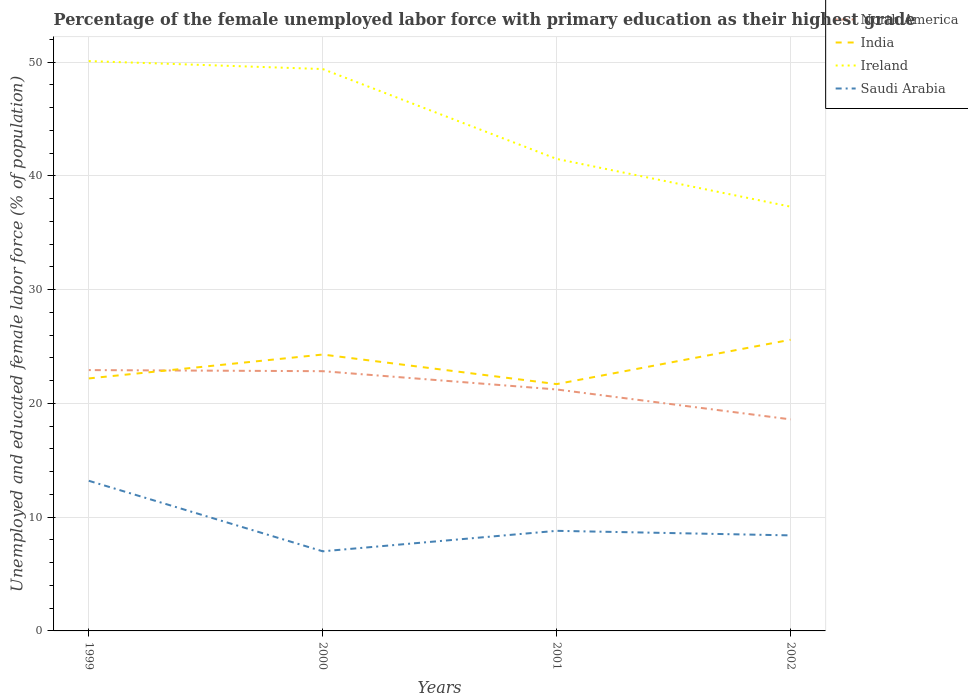Does the line corresponding to Ireland intersect with the line corresponding to India?
Your answer should be very brief. No. Is the number of lines equal to the number of legend labels?
Your answer should be compact. Yes. Across all years, what is the maximum percentage of the unemployed female labor force with primary education in India?
Give a very brief answer. 21.7. In which year was the percentage of the unemployed female labor force with primary education in Ireland maximum?
Your response must be concise. 2002. What is the total percentage of the unemployed female labor force with primary education in North America in the graph?
Your response must be concise. 1.61. What is the difference between the highest and the second highest percentage of the unemployed female labor force with primary education in Saudi Arabia?
Your answer should be compact. 6.2. Is the percentage of the unemployed female labor force with primary education in Saudi Arabia strictly greater than the percentage of the unemployed female labor force with primary education in India over the years?
Your response must be concise. Yes. How many lines are there?
Give a very brief answer. 4. How many years are there in the graph?
Keep it short and to the point. 4. What is the difference between two consecutive major ticks on the Y-axis?
Offer a very short reply. 10. Does the graph contain any zero values?
Your answer should be very brief. No. Does the graph contain grids?
Your answer should be very brief. Yes. Where does the legend appear in the graph?
Make the answer very short. Top right. What is the title of the graph?
Make the answer very short. Percentage of the female unemployed labor force with primary education as their highest grade. Does "Namibia" appear as one of the legend labels in the graph?
Offer a terse response. No. What is the label or title of the Y-axis?
Your answer should be compact. Unemployed and educated female labor force (% of population). What is the Unemployed and educated female labor force (% of population) of North America in 1999?
Your answer should be very brief. 22.93. What is the Unemployed and educated female labor force (% of population) of India in 1999?
Your answer should be very brief. 22.2. What is the Unemployed and educated female labor force (% of population) in Ireland in 1999?
Keep it short and to the point. 50.1. What is the Unemployed and educated female labor force (% of population) of Saudi Arabia in 1999?
Ensure brevity in your answer.  13.2. What is the Unemployed and educated female labor force (% of population) in North America in 2000?
Your response must be concise. 22.84. What is the Unemployed and educated female labor force (% of population) in India in 2000?
Provide a short and direct response. 24.3. What is the Unemployed and educated female labor force (% of population) of Ireland in 2000?
Provide a short and direct response. 49.4. What is the Unemployed and educated female labor force (% of population) of Saudi Arabia in 2000?
Provide a succinct answer. 7. What is the Unemployed and educated female labor force (% of population) in North America in 2001?
Your answer should be very brief. 21.23. What is the Unemployed and educated female labor force (% of population) of India in 2001?
Provide a succinct answer. 21.7. What is the Unemployed and educated female labor force (% of population) of Ireland in 2001?
Give a very brief answer. 41.5. What is the Unemployed and educated female labor force (% of population) of Saudi Arabia in 2001?
Make the answer very short. 8.8. What is the Unemployed and educated female labor force (% of population) in North America in 2002?
Provide a short and direct response. 18.6. What is the Unemployed and educated female labor force (% of population) of India in 2002?
Offer a terse response. 25.6. What is the Unemployed and educated female labor force (% of population) of Ireland in 2002?
Provide a succinct answer. 37.3. What is the Unemployed and educated female labor force (% of population) in Saudi Arabia in 2002?
Offer a very short reply. 8.4. Across all years, what is the maximum Unemployed and educated female labor force (% of population) of North America?
Keep it short and to the point. 22.93. Across all years, what is the maximum Unemployed and educated female labor force (% of population) in India?
Make the answer very short. 25.6. Across all years, what is the maximum Unemployed and educated female labor force (% of population) in Ireland?
Make the answer very short. 50.1. Across all years, what is the maximum Unemployed and educated female labor force (% of population) in Saudi Arabia?
Your answer should be compact. 13.2. Across all years, what is the minimum Unemployed and educated female labor force (% of population) in North America?
Your answer should be very brief. 18.6. Across all years, what is the minimum Unemployed and educated female labor force (% of population) of India?
Your response must be concise. 21.7. Across all years, what is the minimum Unemployed and educated female labor force (% of population) in Ireland?
Provide a succinct answer. 37.3. Across all years, what is the minimum Unemployed and educated female labor force (% of population) of Saudi Arabia?
Make the answer very short. 7. What is the total Unemployed and educated female labor force (% of population) of North America in the graph?
Offer a terse response. 85.6. What is the total Unemployed and educated female labor force (% of population) of India in the graph?
Your answer should be very brief. 93.8. What is the total Unemployed and educated female labor force (% of population) of Ireland in the graph?
Your answer should be very brief. 178.3. What is the total Unemployed and educated female labor force (% of population) in Saudi Arabia in the graph?
Offer a terse response. 37.4. What is the difference between the Unemployed and educated female labor force (% of population) in North America in 1999 and that in 2000?
Provide a succinct answer. 0.1. What is the difference between the Unemployed and educated female labor force (% of population) of North America in 1999 and that in 2001?
Offer a very short reply. 1.7. What is the difference between the Unemployed and educated female labor force (% of population) in Ireland in 1999 and that in 2001?
Offer a terse response. 8.6. What is the difference between the Unemployed and educated female labor force (% of population) in North America in 1999 and that in 2002?
Keep it short and to the point. 4.33. What is the difference between the Unemployed and educated female labor force (% of population) of Ireland in 1999 and that in 2002?
Provide a succinct answer. 12.8. What is the difference between the Unemployed and educated female labor force (% of population) in Saudi Arabia in 1999 and that in 2002?
Provide a succinct answer. 4.8. What is the difference between the Unemployed and educated female labor force (% of population) of North America in 2000 and that in 2001?
Give a very brief answer. 1.61. What is the difference between the Unemployed and educated female labor force (% of population) of North America in 2000 and that in 2002?
Your answer should be very brief. 4.24. What is the difference between the Unemployed and educated female labor force (% of population) in India in 2000 and that in 2002?
Provide a short and direct response. -1.3. What is the difference between the Unemployed and educated female labor force (% of population) in Ireland in 2000 and that in 2002?
Ensure brevity in your answer.  12.1. What is the difference between the Unemployed and educated female labor force (% of population) in North America in 2001 and that in 2002?
Offer a terse response. 2.63. What is the difference between the Unemployed and educated female labor force (% of population) of Ireland in 2001 and that in 2002?
Your answer should be very brief. 4.2. What is the difference between the Unemployed and educated female labor force (% of population) of North America in 1999 and the Unemployed and educated female labor force (% of population) of India in 2000?
Offer a terse response. -1.37. What is the difference between the Unemployed and educated female labor force (% of population) of North America in 1999 and the Unemployed and educated female labor force (% of population) of Ireland in 2000?
Your answer should be very brief. -26.47. What is the difference between the Unemployed and educated female labor force (% of population) in North America in 1999 and the Unemployed and educated female labor force (% of population) in Saudi Arabia in 2000?
Keep it short and to the point. 15.93. What is the difference between the Unemployed and educated female labor force (% of population) in India in 1999 and the Unemployed and educated female labor force (% of population) in Ireland in 2000?
Offer a very short reply. -27.2. What is the difference between the Unemployed and educated female labor force (% of population) of Ireland in 1999 and the Unemployed and educated female labor force (% of population) of Saudi Arabia in 2000?
Make the answer very short. 43.1. What is the difference between the Unemployed and educated female labor force (% of population) of North America in 1999 and the Unemployed and educated female labor force (% of population) of India in 2001?
Your answer should be compact. 1.23. What is the difference between the Unemployed and educated female labor force (% of population) of North America in 1999 and the Unemployed and educated female labor force (% of population) of Ireland in 2001?
Your answer should be very brief. -18.57. What is the difference between the Unemployed and educated female labor force (% of population) in North America in 1999 and the Unemployed and educated female labor force (% of population) in Saudi Arabia in 2001?
Keep it short and to the point. 14.13. What is the difference between the Unemployed and educated female labor force (% of population) in India in 1999 and the Unemployed and educated female labor force (% of population) in Ireland in 2001?
Offer a very short reply. -19.3. What is the difference between the Unemployed and educated female labor force (% of population) in India in 1999 and the Unemployed and educated female labor force (% of population) in Saudi Arabia in 2001?
Your response must be concise. 13.4. What is the difference between the Unemployed and educated female labor force (% of population) of Ireland in 1999 and the Unemployed and educated female labor force (% of population) of Saudi Arabia in 2001?
Provide a succinct answer. 41.3. What is the difference between the Unemployed and educated female labor force (% of population) in North America in 1999 and the Unemployed and educated female labor force (% of population) in India in 2002?
Give a very brief answer. -2.67. What is the difference between the Unemployed and educated female labor force (% of population) in North America in 1999 and the Unemployed and educated female labor force (% of population) in Ireland in 2002?
Your response must be concise. -14.37. What is the difference between the Unemployed and educated female labor force (% of population) of North America in 1999 and the Unemployed and educated female labor force (% of population) of Saudi Arabia in 2002?
Keep it short and to the point. 14.53. What is the difference between the Unemployed and educated female labor force (% of population) in India in 1999 and the Unemployed and educated female labor force (% of population) in Ireland in 2002?
Your answer should be very brief. -15.1. What is the difference between the Unemployed and educated female labor force (% of population) in Ireland in 1999 and the Unemployed and educated female labor force (% of population) in Saudi Arabia in 2002?
Your answer should be very brief. 41.7. What is the difference between the Unemployed and educated female labor force (% of population) of North America in 2000 and the Unemployed and educated female labor force (% of population) of India in 2001?
Your answer should be compact. 1.14. What is the difference between the Unemployed and educated female labor force (% of population) of North America in 2000 and the Unemployed and educated female labor force (% of population) of Ireland in 2001?
Your answer should be very brief. -18.66. What is the difference between the Unemployed and educated female labor force (% of population) of North America in 2000 and the Unemployed and educated female labor force (% of population) of Saudi Arabia in 2001?
Keep it short and to the point. 14.04. What is the difference between the Unemployed and educated female labor force (% of population) in India in 2000 and the Unemployed and educated female labor force (% of population) in Ireland in 2001?
Provide a short and direct response. -17.2. What is the difference between the Unemployed and educated female labor force (% of population) in India in 2000 and the Unemployed and educated female labor force (% of population) in Saudi Arabia in 2001?
Your answer should be very brief. 15.5. What is the difference between the Unemployed and educated female labor force (% of population) in Ireland in 2000 and the Unemployed and educated female labor force (% of population) in Saudi Arabia in 2001?
Make the answer very short. 40.6. What is the difference between the Unemployed and educated female labor force (% of population) in North America in 2000 and the Unemployed and educated female labor force (% of population) in India in 2002?
Offer a very short reply. -2.76. What is the difference between the Unemployed and educated female labor force (% of population) of North America in 2000 and the Unemployed and educated female labor force (% of population) of Ireland in 2002?
Give a very brief answer. -14.46. What is the difference between the Unemployed and educated female labor force (% of population) in North America in 2000 and the Unemployed and educated female labor force (% of population) in Saudi Arabia in 2002?
Give a very brief answer. 14.44. What is the difference between the Unemployed and educated female labor force (% of population) in India in 2000 and the Unemployed and educated female labor force (% of population) in Ireland in 2002?
Provide a succinct answer. -13. What is the difference between the Unemployed and educated female labor force (% of population) in Ireland in 2000 and the Unemployed and educated female labor force (% of population) in Saudi Arabia in 2002?
Your answer should be very brief. 41. What is the difference between the Unemployed and educated female labor force (% of population) of North America in 2001 and the Unemployed and educated female labor force (% of population) of India in 2002?
Offer a terse response. -4.37. What is the difference between the Unemployed and educated female labor force (% of population) of North America in 2001 and the Unemployed and educated female labor force (% of population) of Ireland in 2002?
Provide a succinct answer. -16.07. What is the difference between the Unemployed and educated female labor force (% of population) of North America in 2001 and the Unemployed and educated female labor force (% of population) of Saudi Arabia in 2002?
Your response must be concise. 12.83. What is the difference between the Unemployed and educated female labor force (% of population) in India in 2001 and the Unemployed and educated female labor force (% of population) in Ireland in 2002?
Keep it short and to the point. -15.6. What is the difference between the Unemployed and educated female labor force (% of population) in India in 2001 and the Unemployed and educated female labor force (% of population) in Saudi Arabia in 2002?
Offer a very short reply. 13.3. What is the difference between the Unemployed and educated female labor force (% of population) of Ireland in 2001 and the Unemployed and educated female labor force (% of population) of Saudi Arabia in 2002?
Provide a succinct answer. 33.1. What is the average Unemployed and educated female labor force (% of population) of North America per year?
Offer a terse response. 21.4. What is the average Unemployed and educated female labor force (% of population) of India per year?
Provide a succinct answer. 23.45. What is the average Unemployed and educated female labor force (% of population) in Ireland per year?
Ensure brevity in your answer.  44.58. What is the average Unemployed and educated female labor force (% of population) of Saudi Arabia per year?
Give a very brief answer. 9.35. In the year 1999, what is the difference between the Unemployed and educated female labor force (% of population) in North America and Unemployed and educated female labor force (% of population) in India?
Your response must be concise. 0.73. In the year 1999, what is the difference between the Unemployed and educated female labor force (% of population) of North America and Unemployed and educated female labor force (% of population) of Ireland?
Give a very brief answer. -27.17. In the year 1999, what is the difference between the Unemployed and educated female labor force (% of population) of North America and Unemployed and educated female labor force (% of population) of Saudi Arabia?
Offer a terse response. 9.73. In the year 1999, what is the difference between the Unemployed and educated female labor force (% of population) of India and Unemployed and educated female labor force (% of population) of Ireland?
Provide a short and direct response. -27.9. In the year 1999, what is the difference between the Unemployed and educated female labor force (% of population) of Ireland and Unemployed and educated female labor force (% of population) of Saudi Arabia?
Offer a very short reply. 36.9. In the year 2000, what is the difference between the Unemployed and educated female labor force (% of population) of North America and Unemployed and educated female labor force (% of population) of India?
Ensure brevity in your answer.  -1.46. In the year 2000, what is the difference between the Unemployed and educated female labor force (% of population) in North America and Unemployed and educated female labor force (% of population) in Ireland?
Provide a short and direct response. -26.56. In the year 2000, what is the difference between the Unemployed and educated female labor force (% of population) of North America and Unemployed and educated female labor force (% of population) of Saudi Arabia?
Your answer should be compact. 15.84. In the year 2000, what is the difference between the Unemployed and educated female labor force (% of population) in India and Unemployed and educated female labor force (% of population) in Ireland?
Ensure brevity in your answer.  -25.1. In the year 2000, what is the difference between the Unemployed and educated female labor force (% of population) in Ireland and Unemployed and educated female labor force (% of population) in Saudi Arabia?
Keep it short and to the point. 42.4. In the year 2001, what is the difference between the Unemployed and educated female labor force (% of population) in North America and Unemployed and educated female labor force (% of population) in India?
Provide a succinct answer. -0.47. In the year 2001, what is the difference between the Unemployed and educated female labor force (% of population) in North America and Unemployed and educated female labor force (% of population) in Ireland?
Offer a terse response. -20.27. In the year 2001, what is the difference between the Unemployed and educated female labor force (% of population) of North America and Unemployed and educated female labor force (% of population) of Saudi Arabia?
Keep it short and to the point. 12.43. In the year 2001, what is the difference between the Unemployed and educated female labor force (% of population) in India and Unemployed and educated female labor force (% of population) in Ireland?
Ensure brevity in your answer.  -19.8. In the year 2001, what is the difference between the Unemployed and educated female labor force (% of population) in Ireland and Unemployed and educated female labor force (% of population) in Saudi Arabia?
Give a very brief answer. 32.7. In the year 2002, what is the difference between the Unemployed and educated female labor force (% of population) in North America and Unemployed and educated female labor force (% of population) in India?
Make the answer very short. -7. In the year 2002, what is the difference between the Unemployed and educated female labor force (% of population) in North America and Unemployed and educated female labor force (% of population) in Ireland?
Provide a short and direct response. -18.7. In the year 2002, what is the difference between the Unemployed and educated female labor force (% of population) in North America and Unemployed and educated female labor force (% of population) in Saudi Arabia?
Your answer should be compact. 10.2. In the year 2002, what is the difference between the Unemployed and educated female labor force (% of population) in India and Unemployed and educated female labor force (% of population) in Ireland?
Your answer should be compact. -11.7. In the year 2002, what is the difference between the Unemployed and educated female labor force (% of population) of India and Unemployed and educated female labor force (% of population) of Saudi Arabia?
Offer a terse response. 17.2. In the year 2002, what is the difference between the Unemployed and educated female labor force (% of population) of Ireland and Unemployed and educated female labor force (% of population) of Saudi Arabia?
Offer a terse response. 28.9. What is the ratio of the Unemployed and educated female labor force (% of population) in India in 1999 to that in 2000?
Make the answer very short. 0.91. What is the ratio of the Unemployed and educated female labor force (% of population) in Ireland in 1999 to that in 2000?
Your answer should be very brief. 1.01. What is the ratio of the Unemployed and educated female labor force (% of population) in Saudi Arabia in 1999 to that in 2000?
Provide a succinct answer. 1.89. What is the ratio of the Unemployed and educated female labor force (% of population) in North America in 1999 to that in 2001?
Provide a short and direct response. 1.08. What is the ratio of the Unemployed and educated female labor force (% of population) of India in 1999 to that in 2001?
Offer a very short reply. 1.02. What is the ratio of the Unemployed and educated female labor force (% of population) of Ireland in 1999 to that in 2001?
Offer a terse response. 1.21. What is the ratio of the Unemployed and educated female labor force (% of population) in Saudi Arabia in 1999 to that in 2001?
Keep it short and to the point. 1.5. What is the ratio of the Unemployed and educated female labor force (% of population) of North America in 1999 to that in 2002?
Offer a very short reply. 1.23. What is the ratio of the Unemployed and educated female labor force (% of population) of India in 1999 to that in 2002?
Make the answer very short. 0.87. What is the ratio of the Unemployed and educated female labor force (% of population) in Ireland in 1999 to that in 2002?
Keep it short and to the point. 1.34. What is the ratio of the Unemployed and educated female labor force (% of population) in Saudi Arabia in 1999 to that in 2002?
Make the answer very short. 1.57. What is the ratio of the Unemployed and educated female labor force (% of population) of North America in 2000 to that in 2001?
Your answer should be compact. 1.08. What is the ratio of the Unemployed and educated female labor force (% of population) in India in 2000 to that in 2001?
Offer a terse response. 1.12. What is the ratio of the Unemployed and educated female labor force (% of population) of Ireland in 2000 to that in 2001?
Make the answer very short. 1.19. What is the ratio of the Unemployed and educated female labor force (% of population) of Saudi Arabia in 2000 to that in 2001?
Ensure brevity in your answer.  0.8. What is the ratio of the Unemployed and educated female labor force (% of population) of North America in 2000 to that in 2002?
Give a very brief answer. 1.23. What is the ratio of the Unemployed and educated female labor force (% of population) of India in 2000 to that in 2002?
Your answer should be compact. 0.95. What is the ratio of the Unemployed and educated female labor force (% of population) in Ireland in 2000 to that in 2002?
Make the answer very short. 1.32. What is the ratio of the Unemployed and educated female labor force (% of population) of Saudi Arabia in 2000 to that in 2002?
Ensure brevity in your answer.  0.83. What is the ratio of the Unemployed and educated female labor force (% of population) of North America in 2001 to that in 2002?
Keep it short and to the point. 1.14. What is the ratio of the Unemployed and educated female labor force (% of population) in India in 2001 to that in 2002?
Offer a terse response. 0.85. What is the ratio of the Unemployed and educated female labor force (% of population) in Ireland in 2001 to that in 2002?
Keep it short and to the point. 1.11. What is the ratio of the Unemployed and educated female labor force (% of population) of Saudi Arabia in 2001 to that in 2002?
Your response must be concise. 1.05. What is the difference between the highest and the second highest Unemployed and educated female labor force (% of population) of North America?
Offer a terse response. 0.1. What is the difference between the highest and the second highest Unemployed and educated female labor force (% of population) in Saudi Arabia?
Provide a succinct answer. 4.4. What is the difference between the highest and the lowest Unemployed and educated female labor force (% of population) in North America?
Ensure brevity in your answer.  4.33. What is the difference between the highest and the lowest Unemployed and educated female labor force (% of population) in India?
Provide a short and direct response. 3.9. What is the difference between the highest and the lowest Unemployed and educated female labor force (% of population) of Saudi Arabia?
Provide a succinct answer. 6.2. 